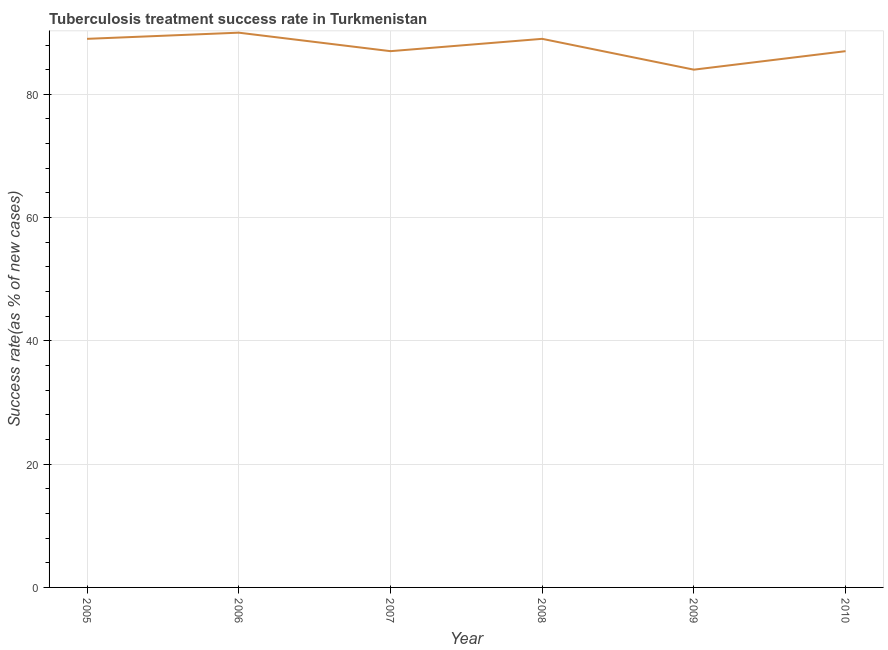What is the tuberculosis treatment success rate in 2008?
Keep it short and to the point. 89. Across all years, what is the maximum tuberculosis treatment success rate?
Offer a very short reply. 90. Across all years, what is the minimum tuberculosis treatment success rate?
Provide a short and direct response. 84. In which year was the tuberculosis treatment success rate minimum?
Give a very brief answer. 2009. What is the sum of the tuberculosis treatment success rate?
Your answer should be compact. 526. What is the difference between the tuberculosis treatment success rate in 2008 and 2010?
Provide a short and direct response. 2. What is the average tuberculosis treatment success rate per year?
Your answer should be compact. 87.67. What is the median tuberculosis treatment success rate?
Give a very brief answer. 88. Do a majority of the years between 2010 and 2006 (inclusive) have tuberculosis treatment success rate greater than 40 %?
Offer a terse response. Yes. What is the ratio of the tuberculosis treatment success rate in 2006 to that in 2007?
Ensure brevity in your answer.  1.03. Is the tuberculosis treatment success rate in 2005 less than that in 2009?
Your answer should be very brief. No. Is the difference between the tuberculosis treatment success rate in 2005 and 2008 greater than the difference between any two years?
Ensure brevity in your answer.  No. What is the difference between the highest and the second highest tuberculosis treatment success rate?
Your answer should be compact. 1. What is the difference between the highest and the lowest tuberculosis treatment success rate?
Your answer should be very brief. 6. Does the tuberculosis treatment success rate monotonically increase over the years?
Offer a very short reply. No. How many years are there in the graph?
Your answer should be compact. 6. Are the values on the major ticks of Y-axis written in scientific E-notation?
Ensure brevity in your answer.  No. Does the graph contain any zero values?
Keep it short and to the point. No. What is the title of the graph?
Your answer should be very brief. Tuberculosis treatment success rate in Turkmenistan. What is the label or title of the Y-axis?
Keep it short and to the point. Success rate(as % of new cases). What is the Success rate(as % of new cases) in 2005?
Give a very brief answer. 89. What is the Success rate(as % of new cases) in 2006?
Your response must be concise. 90. What is the Success rate(as % of new cases) in 2007?
Your answer should be very brief. 87. What is the Success rate(as % of new cases) in 2008?
Offer a very short reply. 89. What is the Success rate(as % of new cases) in 2009?
Offer a very short reply. 84. What is the difference between the Success rate(as % of new cases) in 2005 and 2010?
Provide a short and direct response. 2. What is the difference between the Success rate(as % of new cases) in 2006 and 2007?
Your answer should be compact. 3. What is the difference between the Success rate(as % of new cases) in 2006 and 2008?
Your answer should be very brief. 1. What is the difference between the Success rate(as % of new cases) in 2006 and 2010?
Your answer should be very brief. 3. What is the difference between the Success rate(as % of new cases) in 2007 and 2008?
Offer a terse response. -2. What is the difference between the Success rate(as % of new cases) in 2009 and 2010?
Make the answer very short. -3. What is the ratio of the Success rate(as % of new cases) in 2005 to that in 2006?
Offer a terse response. 0.99. What is the ratio of the Success rate(as % of new cases) in 2005 to that in 2007?
Keep it short and to the point. 1.02. What is the ratio of the Success rate(as % of new cases) in 2005 to that in 2008?
Provide a succinct answer. 1. What is the ratio of the Success rate(as % of new cases) in 2005 to that in 2009?
Your answer should be compact. 1.06. What is the ratio of the Success rate(as % of new cases) in 2006 to that in 2007?
Give a very brief answer. 1.03. What is the ratio of the Success rate(as % of new cases) in 2006 to that in 2009?
Your answer should be compact. 1.07. What is the ratio of the Success rate(as % of new cases) in 2006 to that in 2010?
Your answer should be compact. 1.03. What is the ratio of the Success rate(as % of new cases) in 2007 to that in 2008?
Keep it short and to the point. 0.98. What is the ratio of the Success rate(as % of new cases) in 2007 to that in 2009?
Keep it short and to the point. 1.04. What is the ratio of the Success rate(as % of new cases) in 2007 to that in 2010?
Your answer should be compact. 1. What is the ratio of the Success rate(as % of new cases) in 2008 to that in 2009?
Keep it short and to the point. 1.06. What is the ratio of the Success rate(as % of new cases) in 2008 to that in 2010?
Keep it short and to the point. 1.02. What is the ratio of the Success rate(as % of new cases) in 2009 to that in 2010?
Your answer should be very brief. 0.97. 